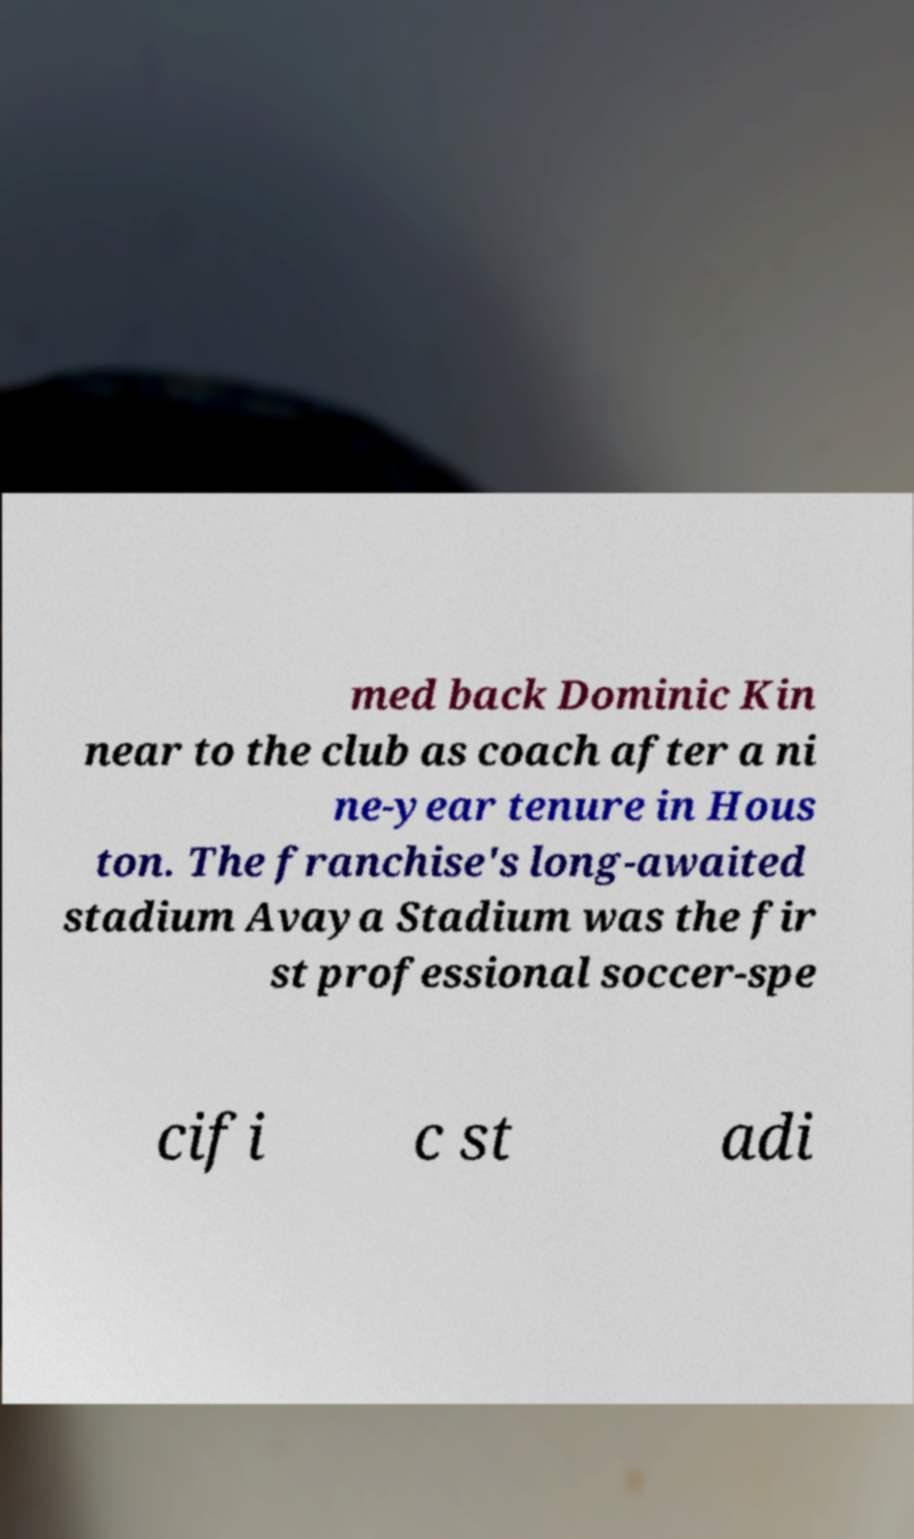For documentation purposes, I need the text within this image transcribed. Could you provide that? med back Dominic Kin near to the club as coach after a ni ne-year tenure in Hous ton. The franchise's long-awaited stadium Avaya Stadium was the fir st professional soccer-spe cifi c st adi 